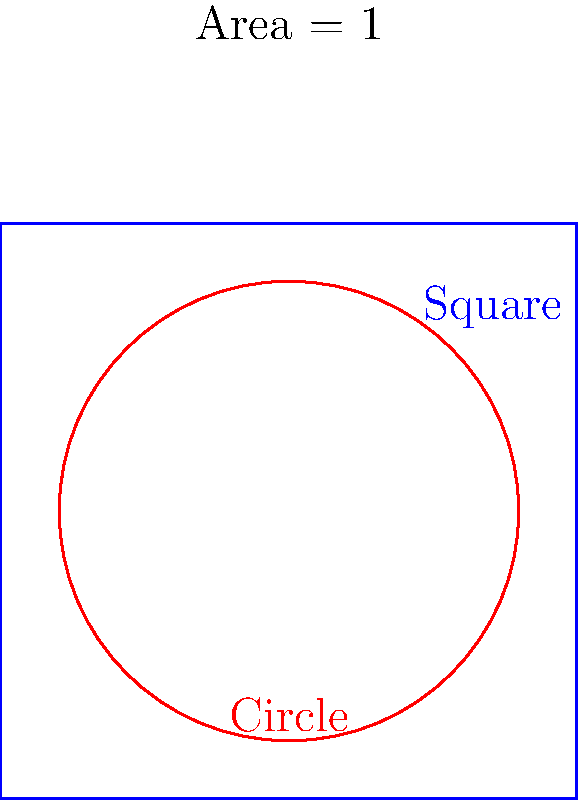In designing community garden plots to maximize space usage, we need to consider the most efficient shape. Given two shapes with the same area of 1 square unit, a square and a circle, which shape has the shorter perimeter and would be more efficient for minimizing fencing costs while maximizing usable garden space? Let's compare the perimeters of a square and a circle, both with an area of 1 square unit:

1. For the square:
   - Area of square = $s^2 = 1$
   - Side length, $s = \sqrt{1} = 1$
   - Perimeter of square = $4s = 4 \cdot 1 = 4$

2. For the circle:
   - Area of circle = $\pi r^2 = 1$
   - Radius, $r = \sqrt{\frac{1}{\pi}}$
   - Perimeter (circumference) of circle = $2\pi r = 2\pi \sqrt{\frac{1}{\pi}} = 2\sqrt{\pi} \approx 3.54$

3. Comparison:
   - Square perimeter: 4
   - Circle perimeter: $2\sqrt{\pi} \approx 3.54$

The circle has a shorter perimeter than the square for the same area.
Answer: Circle 